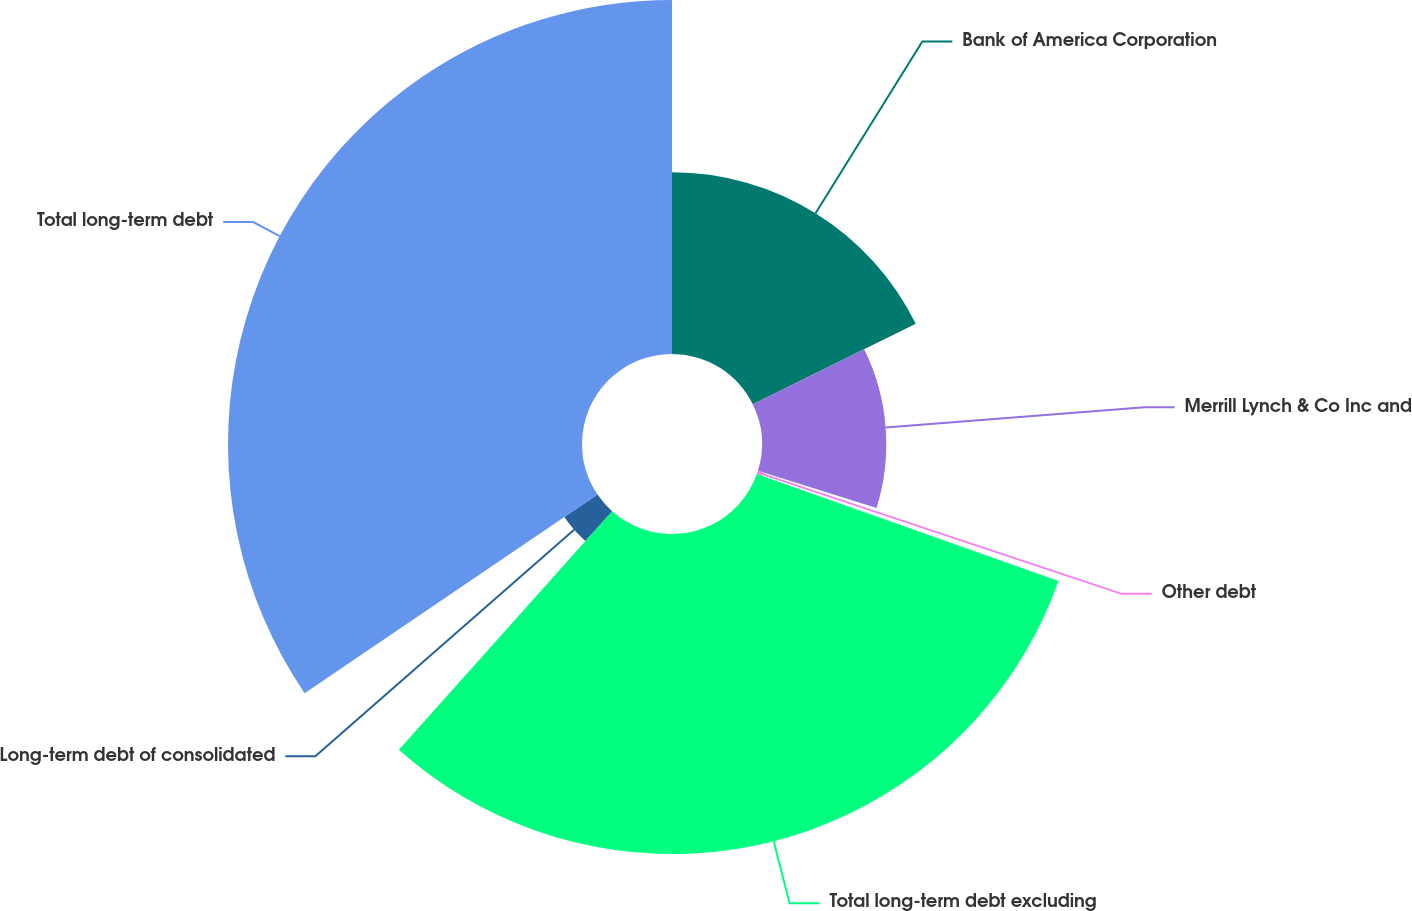Convert chart to OTSL. <chart><loc_0><loc_0><loc_500><loc_500><pie_chart><fcel>Bank of America Corporation<fcel>Merrill Lynch & Co Inc and<fcel>Other debt<fcel>Total long-term debt excluding<fcel>Long-term debt of consolidated<fcel>Total long-term debt<nl><fcel>17.71%<fcel>12.11%<fcel>0.6%<fcel>31.18%<fcel>3.91%<fcel>34.49%<nl></chart> 